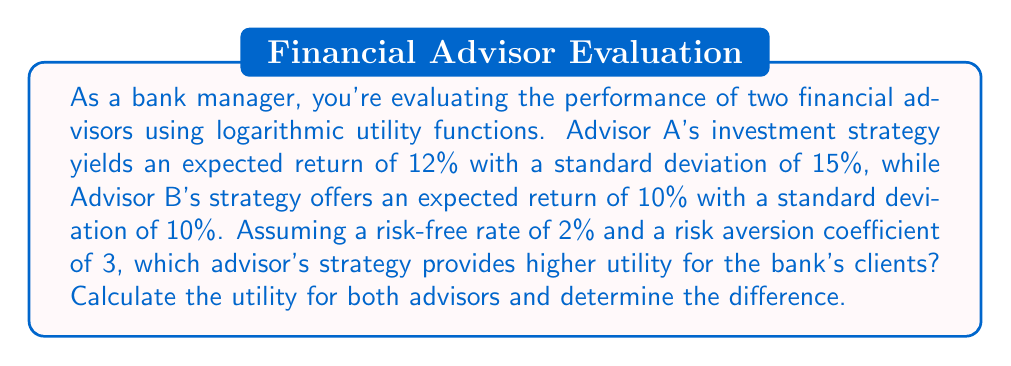Can you answer this question? To solve this problem, we'll use the logarithmic utility function that incorporates risk aversion:

$$U = E[r] - \frac{1}{2} A \sigma^2$$

Where:
$U$ = Utility
$E[r]$ = Expected return
$A$ = Risk aversion coefficient
$\sigma$ = Standard deviation of returns

Step 1: Calculate utility for Advisor A
$$U_A = 0.12 - \frac{1}{2} \cdot 3 \cdot 0.15^2 = 0.12 - 0.03375 = 0.08625$$

Step 2: Calculate utility for Advisor B
$$U_B = 0.10 - \frac{1}{2} \cdot 3 \cdot 0.10^2 = 0.10 - 0.015 = 0.085$$

Step 3: Compare utilities
The difference in utility is:
$$U_A - U_B = 0.08625 - 0.085 = 0.00125$$

Since $U_A > U_B$, Advisor A's strategy provides higher utility for the bank's clients.
Answer: Advisor A's strategy provides higher utility with a value of 0.08625, compared to Advisor B's utility of 0.085. The difference in utility is 0.00125 in favor of Advisor A. 